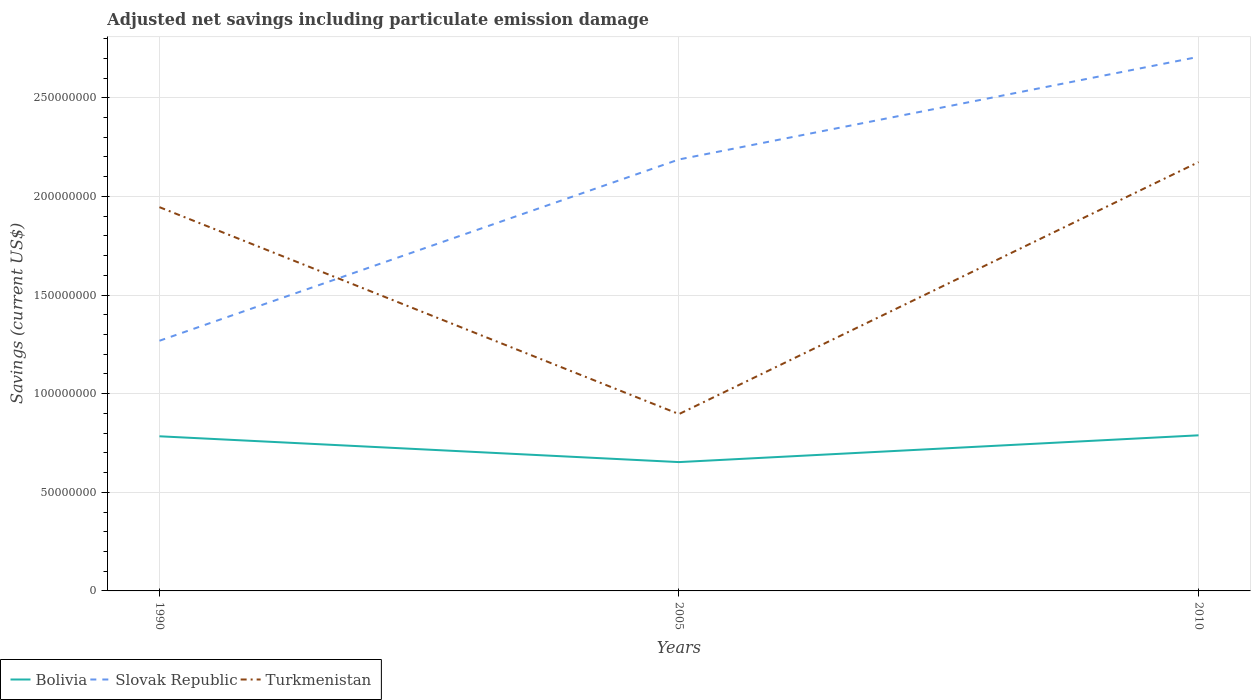How many different coloured lines are there?
Your response must be concise. 3. Across all years, what is the maximum net savings in Slovak Republic?
Make the answer very short. 1.27e+08. In which year was the net savings in Turkmenistan maximum?
Your answer should be compact. 2005. What is the total net savings in Turkmenistan in the graph?
Your answer should be very brief. -2.28e+07. What is the difference between the highest and the second highest net savings in Turkmenistan?
Offer a terse response. 1.28e+08. How many lines are there?
Give a very brief answer. 3. What is the difference between two consecutive major ticks on the Y-axis?
Make the answer very short. 5.00e+07. Does the graph contain any zero values?
Your response must be concise. No. Does the graph contain grids?
Make the answer very short. Yes. How many legend labels are there?
Provide a short and direct response. 3. How are the legend labels stacked?
Ensure brevity in your answer.  Horizontal. What is the title of the graph?
Your answer should be compact. Adjusted net savings including particulate emission damage. Does "Lower middle income" appear as one of the legend labels in the graph?
Your answer should be compact. No. What is the label or title of the Y-axis?
Offer a very short reply. Savings (current US$). What is the Savings (current US$) in Bolivia in 1990?
Keep it short and to the point. 7.84e+07. What is the Savings (current US$) of Slovak Republic in 1990?
Make the answer very short. 1.27e+08. What is the Savings (current US$) in Turkmenistan in 1990?
Offer a very short reply. 1.95e+08. What is the Savings (current US$) in Bolivia in 2005?
Your answer should be compact. 6.53e+07. What is the Savings (current US$) in Slovak Republic in 2005?
Offer a terse response. 2.19e+08. What is the Savings (current US$) of Turkmenistan in 2005?
Make the answer very short. 8.96e+07. What is the Savings (current US$) in Bolivia in 2010?
Keep it short and to the point. 7.89e+07. What is the Savings (current US$) of Slovak Republic in 2010?
Ensure brevity in your answer.  2.71e+08. What is the Savings (current US$) of Turkmenistan in 2010?
Keep it short and to the point. 2.17e+08. Across all years, what is the maximum Savings (current US$) in Bolivia?
Keep it short and to the point. 7.89e+07. Across all years, what is the maximum Savings (current US$) of Slovak Republic?
Your answer should be compact. 2.71e+08. Across all years, what is the maximum Savings (current US$) in Turkmenistan?
Give a very brief answer. 2.17e+08. Across all years, what is the minimum Savings (current US$) of Bolivia?
Your answer should be very brief. 6.53e+07. Across all years, what is the minimum Savings (current US$) in Slovak Republic?
Offer a terse response. 1.27e+08. Across all years, what is the minimum Savings (current US$) of Turkmenistan?
Your answer should be very brief. 8.96e+07. What is the total Savings (current US$) of Bolivia in the graph?
Your answer should be compact. 2.23e+08. What is the total Savings (current US$) in Slovak Republic in the graph?
Your answer should be compact. 6.16e+08. What is the total Savings (current US$) of Turkmenistan in the graph?
Provide a short and direct response. 5.02e+08. What is the difference between the Savings (current US$) in Bolivia in 1990 and that in 2005?
Keep it short and to the point. 1.31e+07. What is the difference between the Savings (current US$) of Slovak Republic in 1990 and that in 2005?
Give a very brief answer. -9.19e+07. What is the difference between the Savings (current US$) of Turkmenistan in 1990 and that in 2005?
Ensure brevity in your answer.  1.05e+08. What is the difference between the Savings (current US$) in Bolivia in 1990 and that in 2010?
Offer a very short reply. -4.93e+05. What is the difference between the Savings (current US$) of Slovak Republic in 1990 and that in 2010?
Your answer should be very brief. -1.44e+08. What is the difference between the Savings (current US$) in Turkmenistan in 1990 and that in 2010?
Offer a very short reply. -2.28e+07. What is the difference between the Savings (current US$) of Bolivia in 2005 and that in 2010?
Keep it short and to the point. -1.36e+07. What is the difference between the Savings (current US$) of Slovak Republic in 2005 and that in 2010?
Your response must be concise. -5.20e+07. What is the difference between the Savings (current US$) in Turkmenistan in 2005 and that in 2010?
Provide a short and direct response. -1.28e+08. What is the difference between the Savings (current US$) in Bolivia in 1990 and the Savings (current US$) in Slovak Republic in 2005?
Offer a very short reply. -1.40e+08. What is the difference between the Savings (current US$) in Bolivia in 1990 and the Savings (current US$) in Turkmenistan in 2005?
Make the answer very short. -1.13e+07. What is the difference between the Savings (current US$) in Slovak Republic in 1990 and the Savings (current US$) in Turkmenistan in 2005?
Offer a terse response. 3.72e+07. What is the difference between the Savings (current US$) in Bolivia in 1990 and the Savings (current US$) in Slovak Republic in 2010?
Provide a succinct answer. -1.92e+08. What is the difference between the Savings (current US$) in Bolivia in 1990 and the Savings (current US$) in Turkmenistan in 2010?
Give a very brief answer. -1.39e+08. What is the difference between the Savings (current US$) of Slovak Republic in 1990 and the Savings (current US$) of Turkmenistan in 2010?
Provide a succinct answer. -9.06e+07. What is the difference between the Savings (current US$) in Bolivia in 2005 and the Savings (current US$) in Slovak Republic in 2010?
Keep it short and to the point. -2.05e+08. What is the difference between the Savings (current US$) in Bolivia in 2005 and the Savings (current US$) in Turkmenistan in 2010?
Provide a succinct answer. -1.52e+08. What is the difference between the Savings (current US$) of Slovak Republic in 2005 and the Savings (current US$) of Turkmenistan in 2010?
Keep it short and to the point. 1.35e+06. What is the average Savings (current US$) of Bolivia per year?
Provide a short and direct response. 7.42e+07. What is the average Savings (current US$) of Slovak Republic per year?
Make the answer very short. 2.05e+08. What is the average Savings (current US$) in Turkmenistan per year?
Offer a very short reply. 1.67e+08. In the year 1990, what is the difference between the Savings (current US$) of Bolivia and Savings (current US$) of Slovak Republic?
Provide a succinct answer. -4.84e+07. In the year 1990, what is the difference between the Savings (current US$) in Bolivia and Savings (current US$) in Turkmenistan?
Give a very brief answer. -1.16e+08. In the year 1990, what is the difference between the Savings (current US$) of Slovak Republic and Savings (current US$) of Turkmenistan?
Make the answer very short. -6.77e+07. In the year 2005, what is the difference between the Savings (current US$) in Bolivia and Savings (current US$) in Slovak Republic?
Your answer should be very brief. -1.53e+08. In the year 2005, what is the difference between the Savings (current US$) of Bolivia and Savings (current US$) of Turkmenistan?
Keep it short and to the point. -2.43e+07. In the year 2005, what is the difference between the Savings (current US$) of Slovak Republic and Savings (current US$) of Turkmenistan?
Offer a very short reply. 1.29e+08. In the year 2010, what is the difference between the Savings (current US$) of Bolivia and Savings (current US$) of Slovak Republic?
Offer a terse response. -1.92e+08. In the year 2010, what is the difference between the Savings (current US$) of Bolivia and Savings (current US$) of Turkmenistan?
Make the answer very short. -1.38e+08. In the year 2010, what is the difference between the Savings (current US$) in Slovak Republic and Savings (current US$) in Turkmenistan?
Provide a succinct answer. 5.34e+07. What is the ratio of the Savings (current US$) of Bolivia in 1990 to that in 2005?
Give a very brief answer. 1.2. What is the ratio of the Savings (current US$) in Slovak Republic in 1990 to that in 2005?
Offer a terse response. 0.58. What is the ratio of the Savings (current US$) in Turkmenistan in 1990 to that in 2005?
Your response must be concise. 2.17. What is the ratio of the Savings (current US$) in Slovak Republic in 1990 to that in 2010?
Make the answer very short. 0.47. What is the ratio of the Savings (current US$) in Turkmenistan in 1990 to that in 2010?
Provide a short and direct response. 0.89. What is the ratio of the Savings (current US$) of Bolivia in 2005 to that in 2010?
Provide a short and direct response. 0.83. What is the ratio of the Savings (current US$) in Slovak Republic in 2005 to that in 2010?
Provide a succinct answer. 0.81. What is the ratio of the Savings (current US$) in Turkmenistan in 2005 to that in 2010?
Your response must be concise. 0.41. What is the difference between the highest and the second highest Savings (current US$) of Bolivia?
Make the answer very short. 4.93e+05. What is the difference between the highest and the second highest Savings (current US$) of Slovak Republic?
Give a very brief answer. 5.20e+07. What is the difference between the highest and the second highest Savings (current US$) in Turkmenistan?
Keep it short and to the point. 2.28e+07. What is the difference between the highest and the lowest Savings (current US$) of Bolivia?
Provide a short and direct response. 1.36e+07. What is the difference between the highest and the lowest Savings (current US$) of Slovak Republic?
Provide a succinct answer. 1.44e+08. What is the difference between the highest and the lowest Savings (current US$) in Turkmenistan?
Your response must be concise. 1.28e+08. 